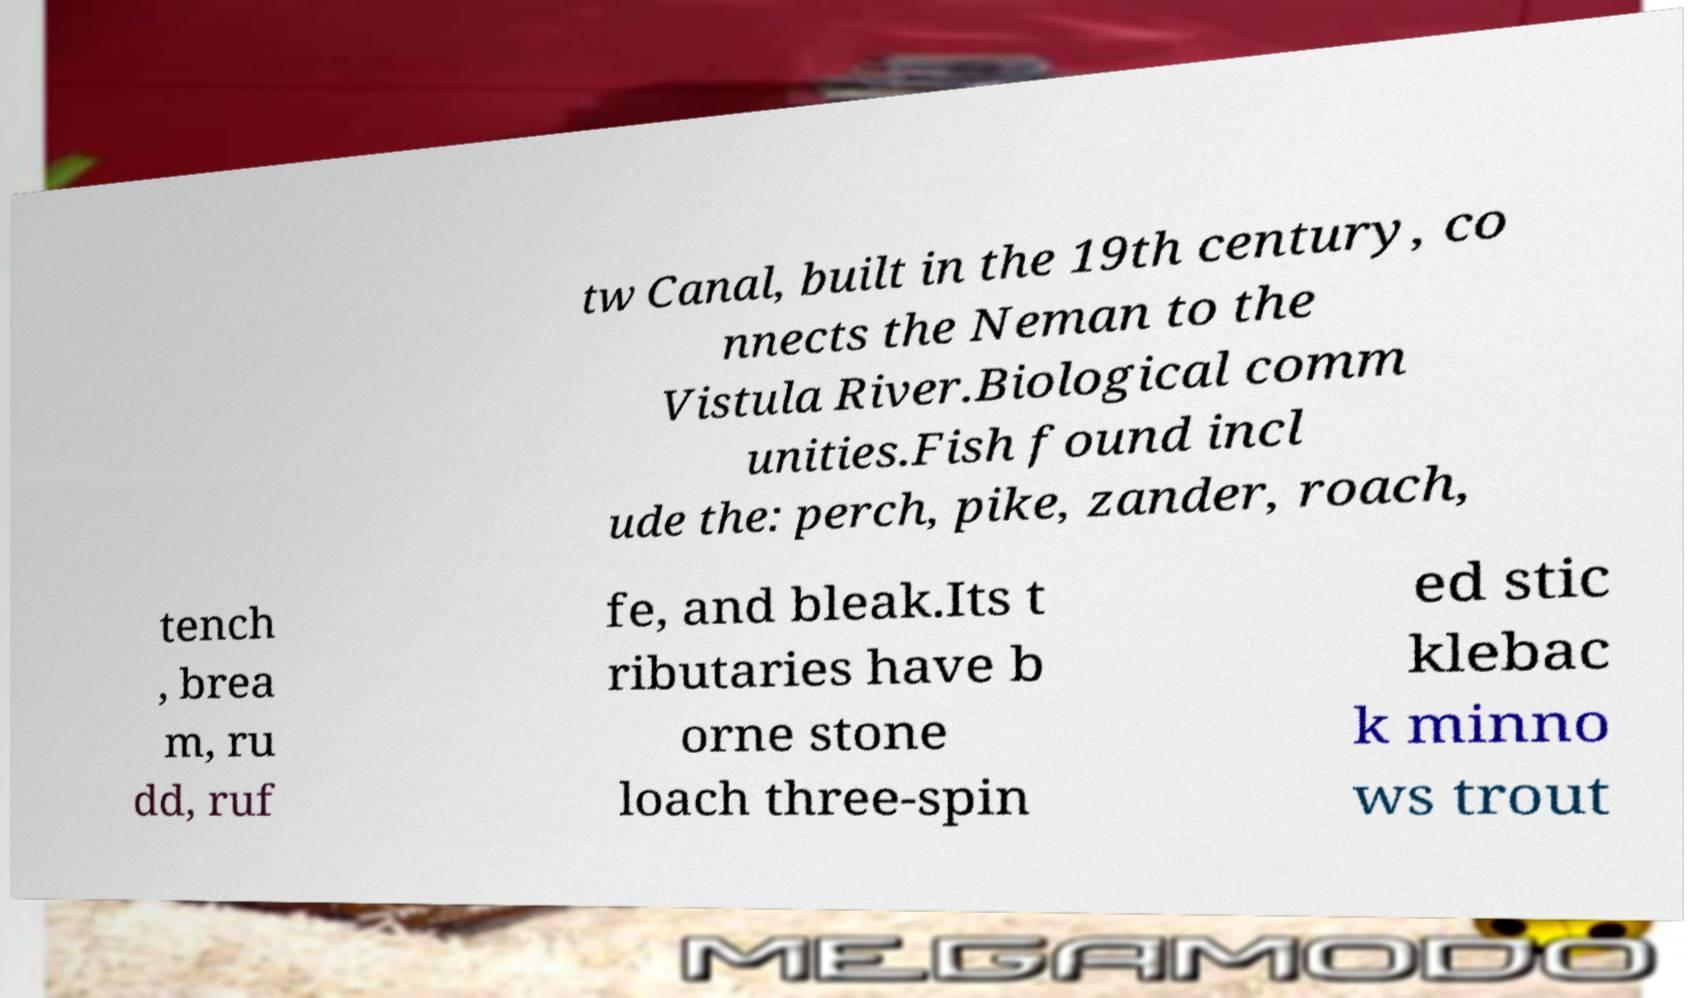I need the written content from this picture converted into text. Can you do that? tw Canal, built in the 19th century, co nnects the Neman to the Vistula River.Biological comm unities.Fish found incl ude the: perch, pike, zander, roach, tench , brea m, ru dd, ruf fe, and bleak.Its t ributaries have b orne stone loach three-spin ed stic klebac k minno ws trout 